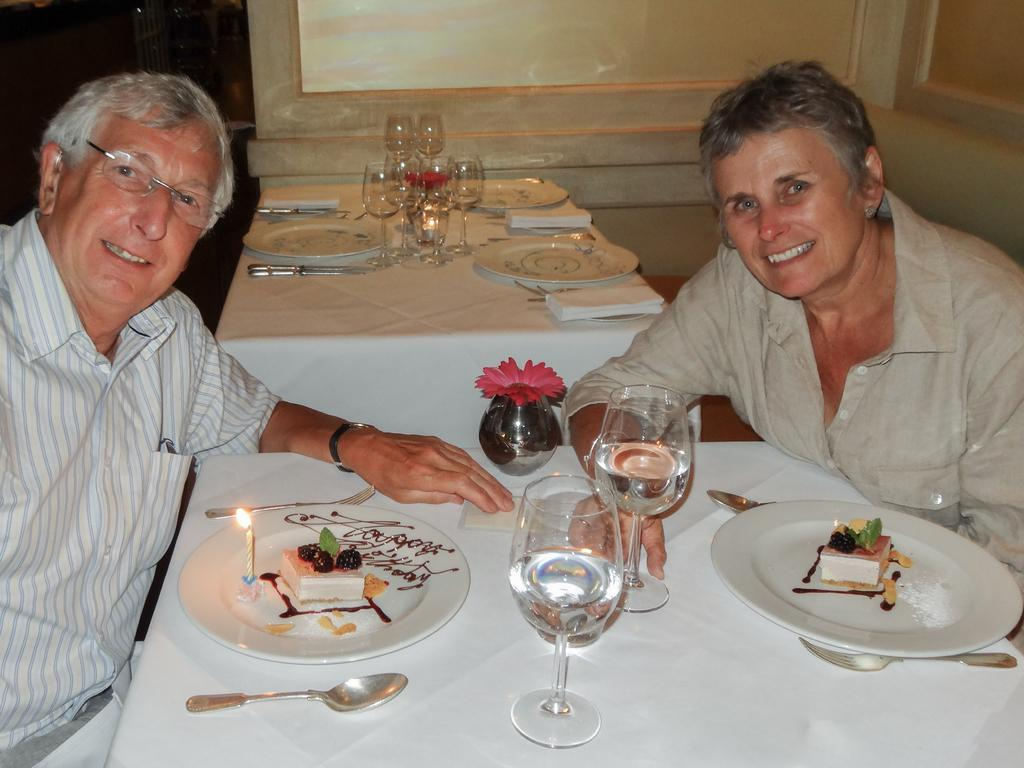How many people are present in the image? There are two persons sitting in the image. What objects are in front of the persons? There are glasses, spoons, and plates in front of the persons. What is on the plates? There is food on the plates. What color is the wall in the background? The wall in the background is cream-colored. What type of nail is being hammered into the wall in the image? There is no nail being hammered into the wall in the image. Can you read the letter that is being written on the plate in the image? There is no letter being written on the plate in the image; it is a plate with food on it. 